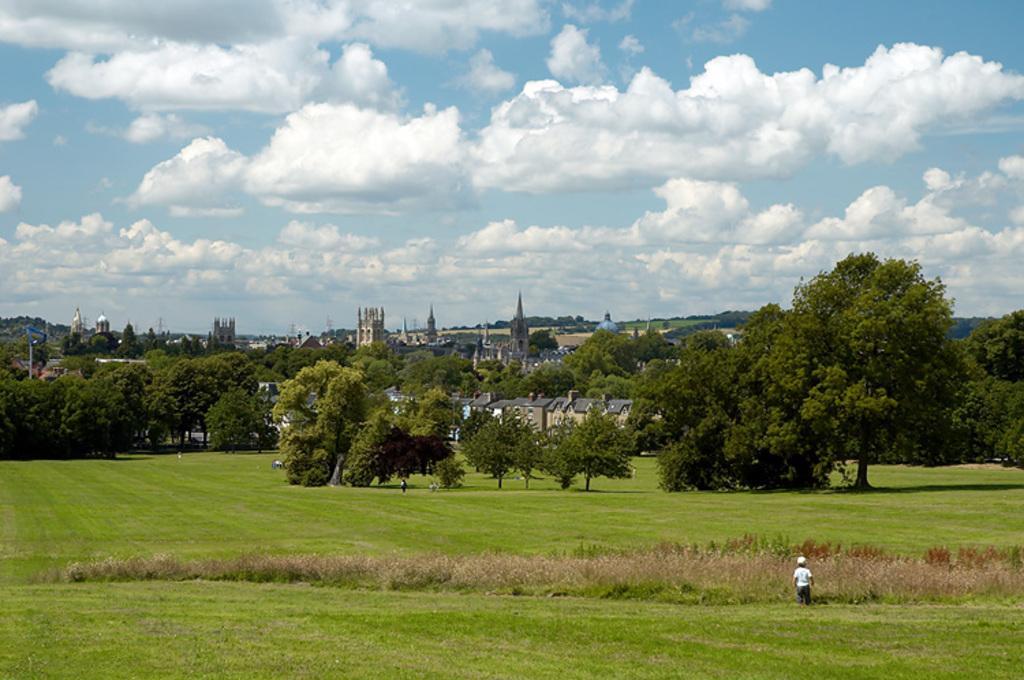Please provide a concise description of this image. At the bottom of the image on the ground there is grass and also there is a small kid. And in the image there are many trees. In between the trees there are buildings. At the top of the image there is sky with clouds. 